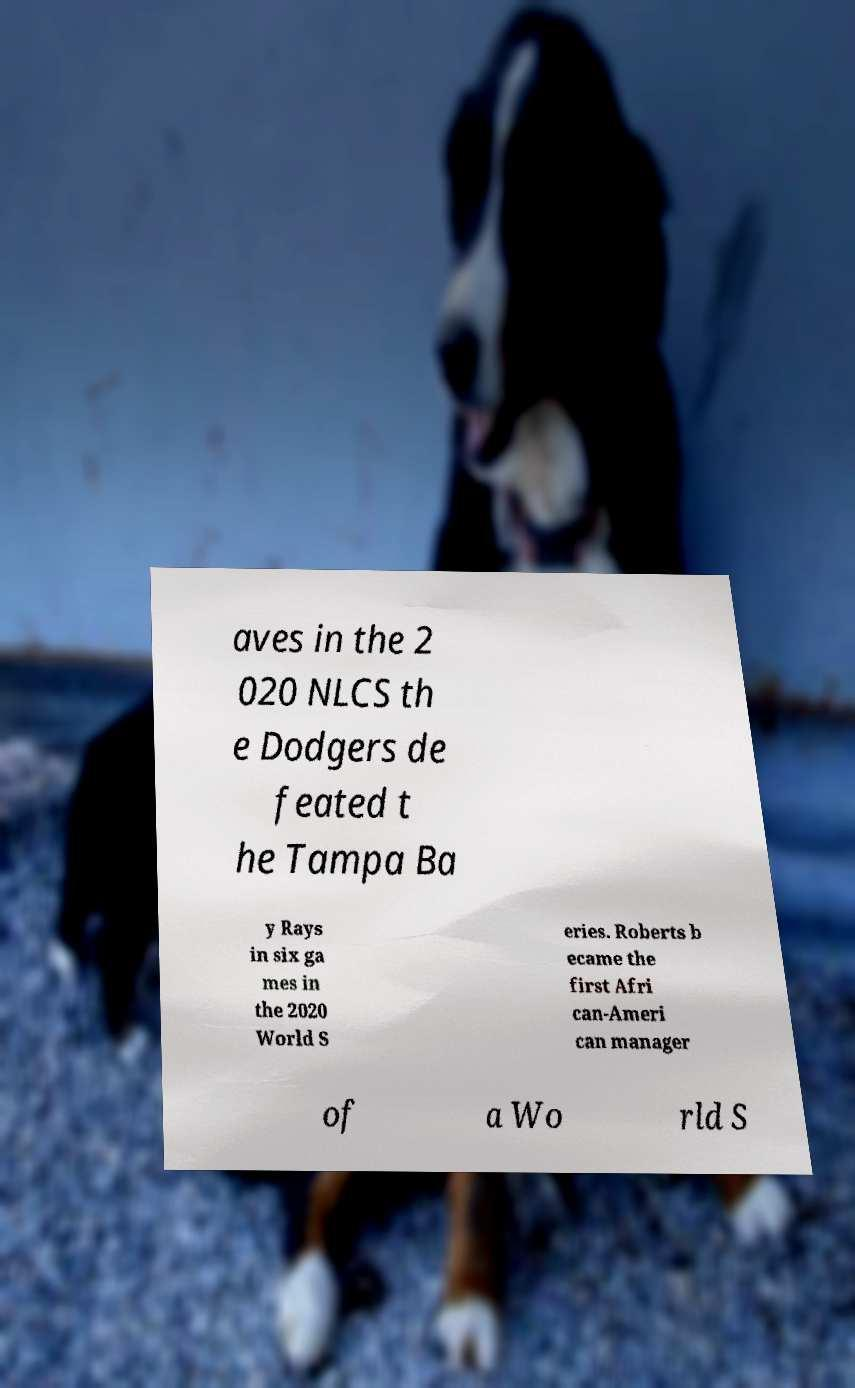Can you read and provide the text displayed in the image?This photo seems to have some interesting text. Can you extract and type it out for me? aves in the 2 020 NLCS th e Dodgers de feated t he Tampa Ba y Rays in six ga mes in the 2020 World S eries. Roberts b ecame the first Afri can-Ameri can manager of a Wo rld S 